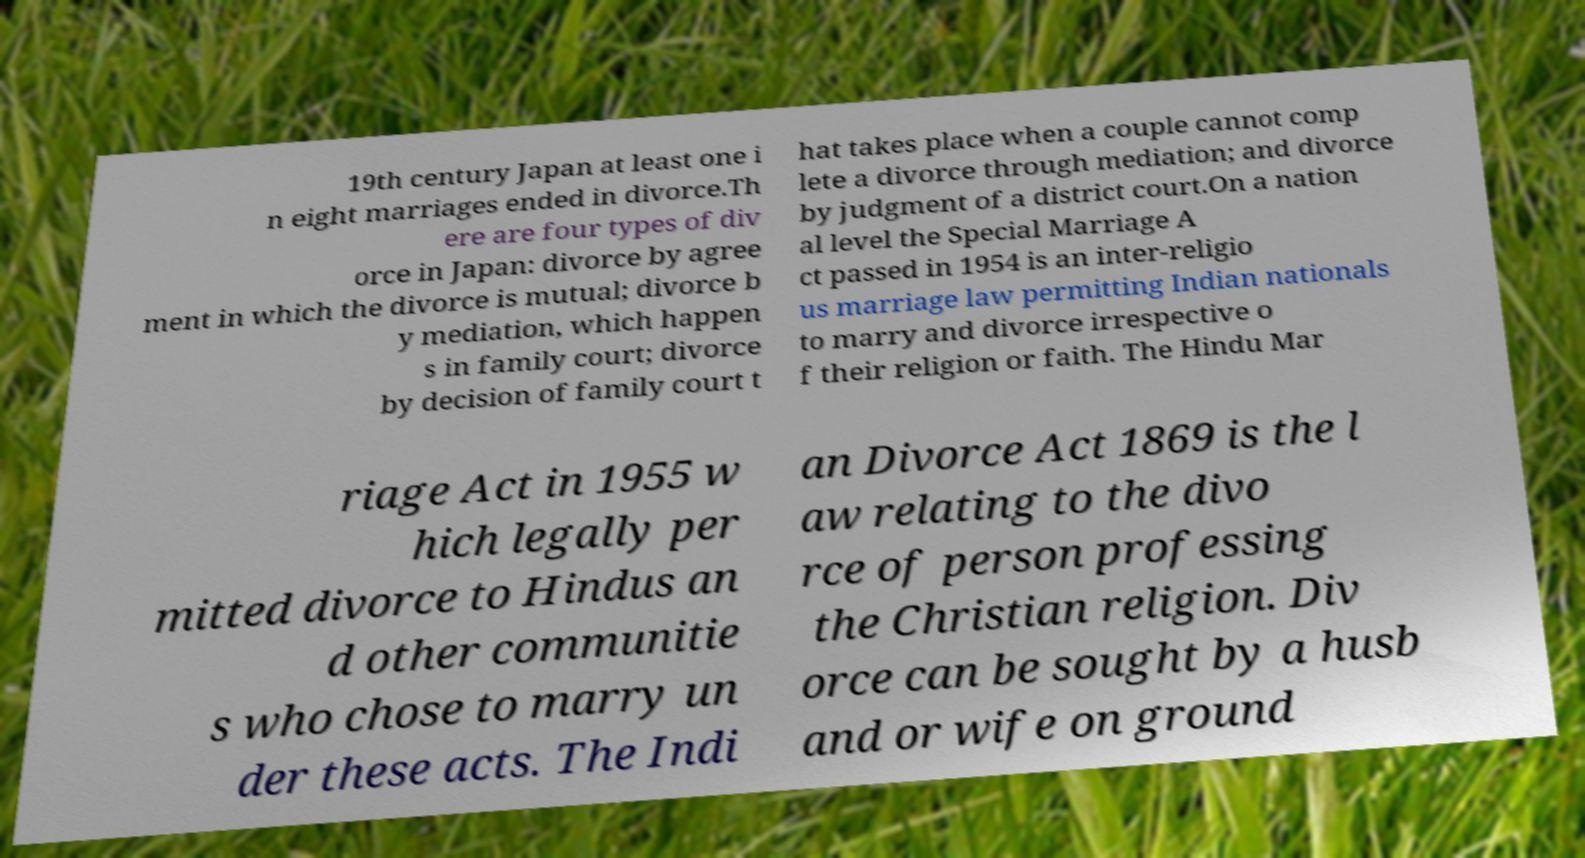I need the written content from this picture converted into text. Can you do that? 19th century Japan at least one i n eight marriages ended in divorce.Th ere are four types of div orce in Japan: divorce by agree ment in which the divorce is mutual; divorce b y mediation, which happen s in family court; divorce by decision of family court t hat takes place when a couple cannot comp lete a divorce through mediation; and divorce by judgment of a district court.On a nation al level the Special Marriage A ct passed in 1954 is an inter-religio us marriage law permitting Indian nationals to marry and divorce irrespective o f their religion or faith. The Hindu Mar riage Act in 1955 w hich legally per mitted divorce to Hindus an d other communitie s who chose to marry un der these acts. The Indi an Divorce Act 1869 is the l aw relating to the divo rce of person professing the Christian religion. Div orce can be sought by a husb and or wife on ground 